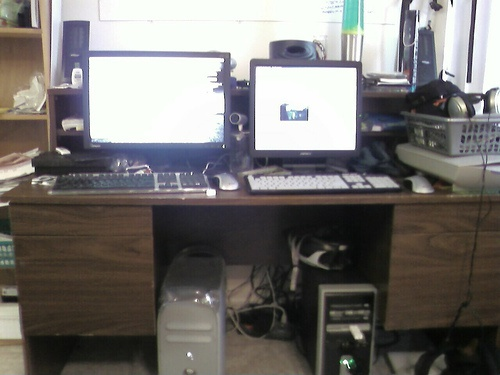Describe the objects in this image and their specific colors. I can see tv in tan, white, and gray tones, tv in tan, white, gray, and black tones, keyboard in tan, gray, darkgray, and black tones, keyboard in tan, lightgray, darkgray, gray, and black tones, and mouse in tan, darkgray, gray, black, and lightgray tones in this image. 